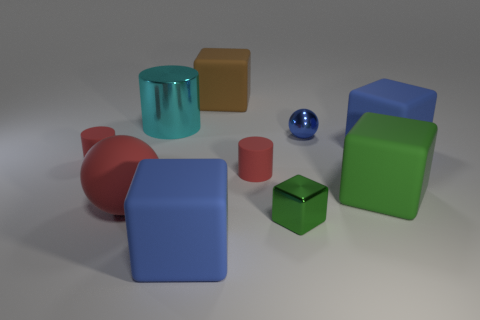Are there any other things that are the same material as the blue sphere?
Keep it short and to the point. Yes. How many other things are the same shape as the brown thing?
Your response must be concise. 4. There is a large blue rubber block behind the small rubber object left of the cyan shiny cylinder; what number of red rubber things are behind it?
Ensure brevity in your answer.  0. What number of large cyan metallic objects are the same shape as the tiny blue object?
Offer a terse response. 0. There is a big rubber sphere that is to the left of the large brown thing; is its color the same as the tiny ball?
Give a very brief answer. No. What shape is the small red object that is to the right of the small red thing that is on the left side of the large cube left of the brown rubber object?
Provide a short and direct response. Cylinder. There is a metal sphere; is its size the same as the blue matte object that is right of the metallic ball?
Your response must be concise. No. Are there any things of the same size as the red matte ball?
Your response must be concise. Yes. What number of other things are there of the same material as the red ball
Make the answer very short. 6. The object that is both behind the green matte object and to the left of the cyan cylinder is what color?
Give a very brief answer. Red. 